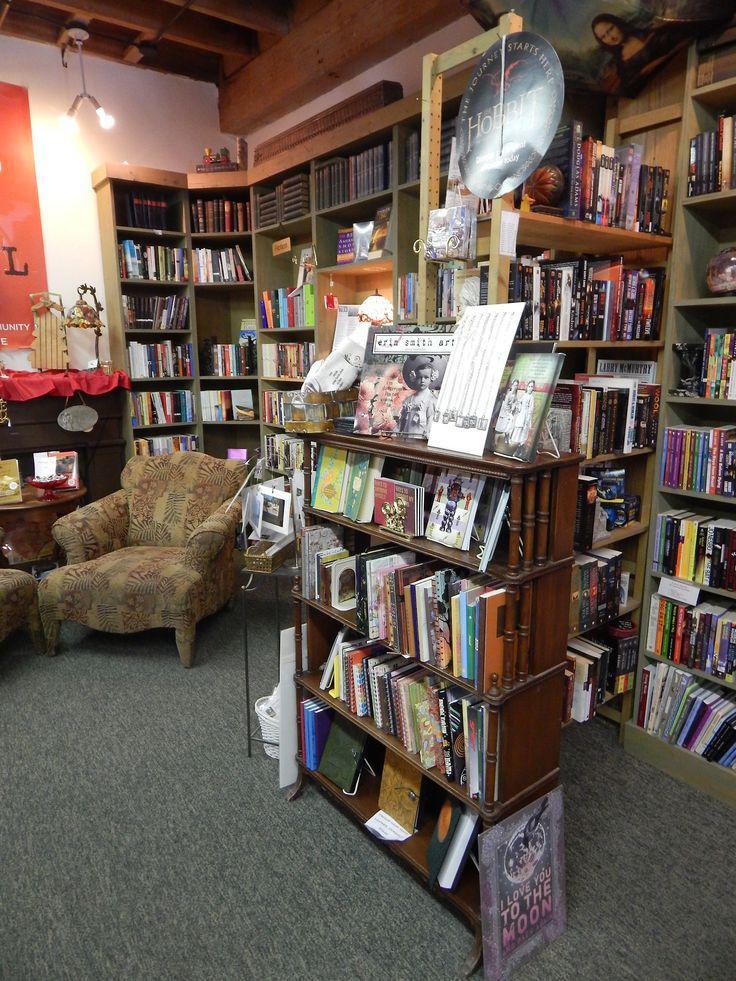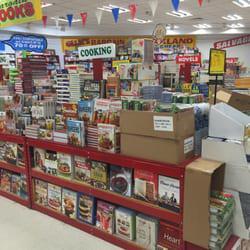The first image is the image on the left, the second image is the image on the right. Evaluate the accuracy of this statement regarding the images: "One image shows an upright furry cartoonish creature in front of items displayed for sale.". Is it true? Answer yes or no. No. The first image is the image on the left, the second image is the image on the right. Evaluate the accuracy of this statement regarding the images: "One of the images features a large stuffed animal/character from a popular book.". Is it true? Answer yes or no. No. 